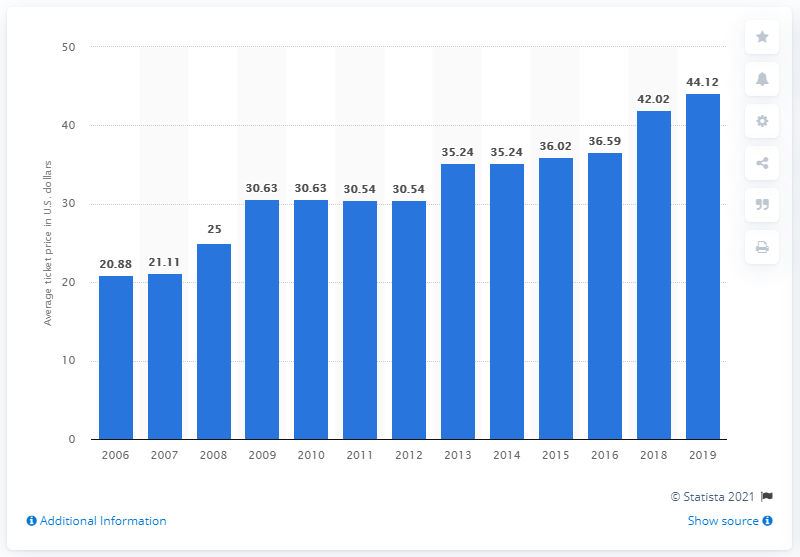Outline some significant characteristics in this image. The average ticket price for Washington Nationals games in 2019 was $44.12. 